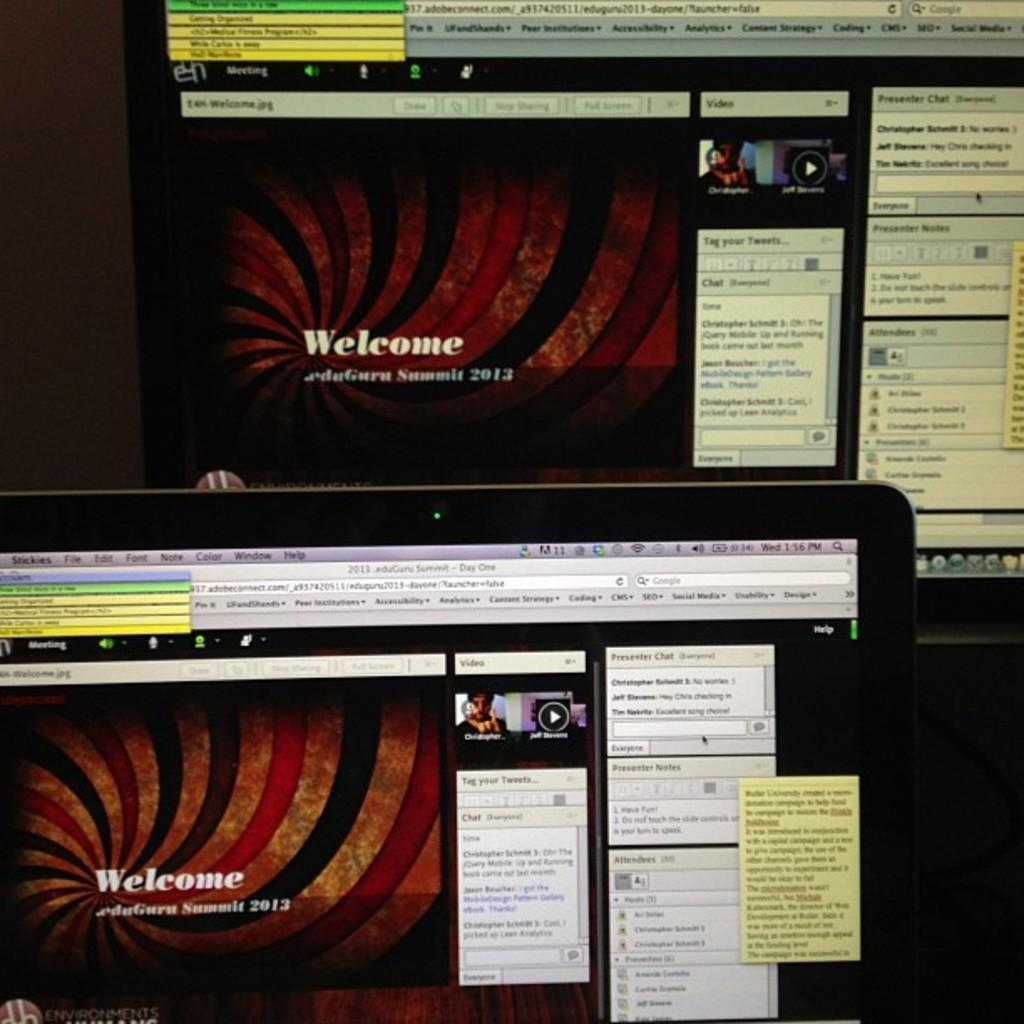<image>
Render a clear and concise summary of the photo. A computer screen showing a presentation that has the words welcome on it 